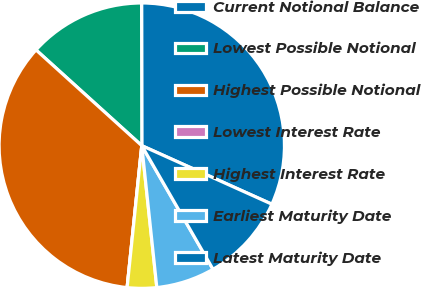Convert chart. <chart><loc_0><loc_0><loc_500><loc_500><pie_chart><fcel>Current Notional Balance<fcel>Lowest Possible Notional<fcel>Highest Possible Notional<fcel>Lowest Interest Rate<fcel>Highest Interest Rate<fcel>Earliest Maturity Date<fcel>Latest Maturity Date<nl><fcel>31.75%<fcel>13.27%<fcel>35.07%<fcel>0.0%<fcel>3.32%<fcel>6.64%<fcel>9.95%<nl></chart> 